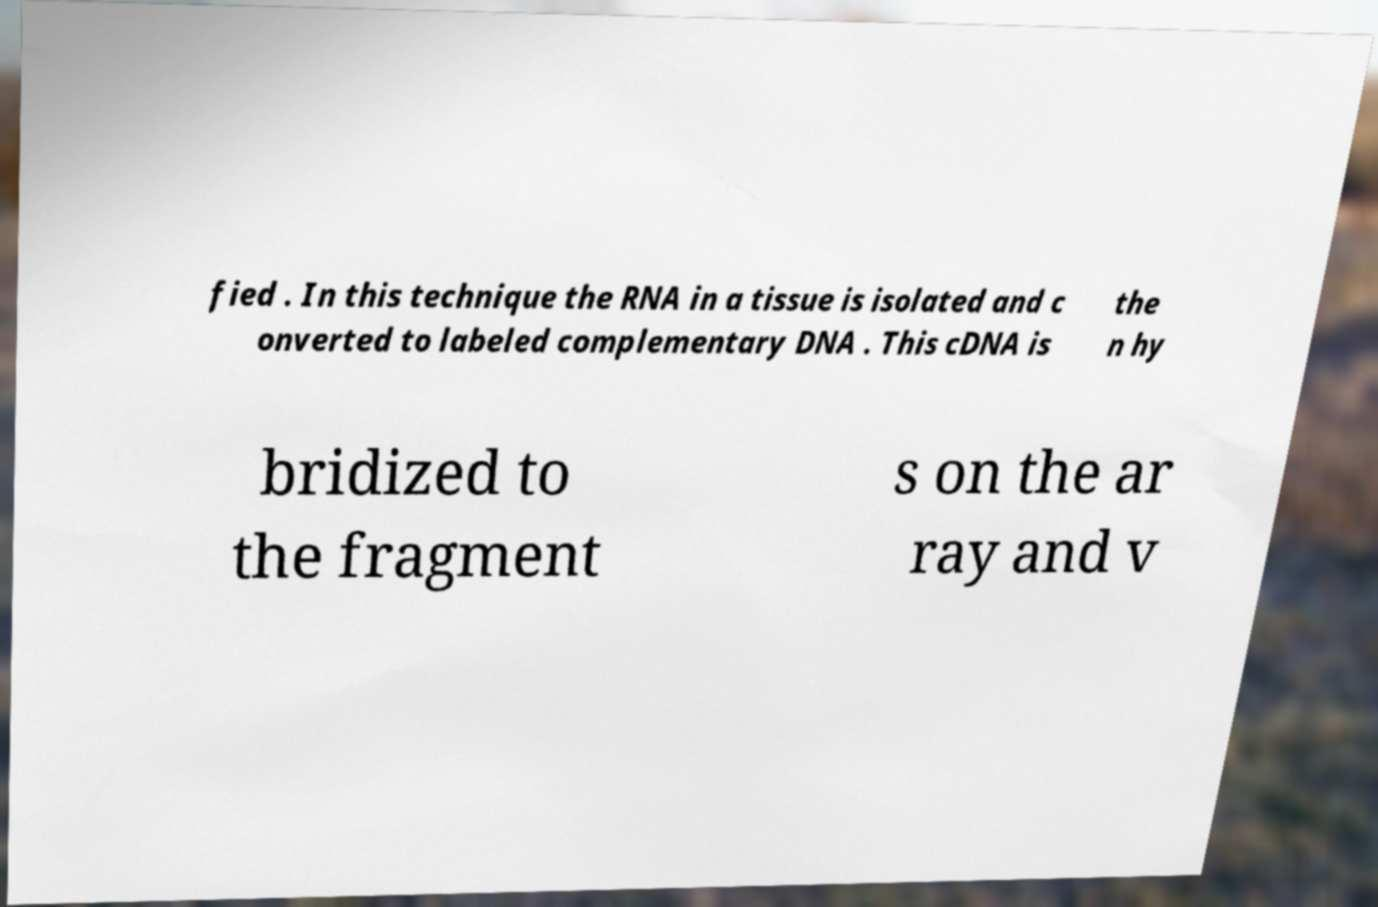Please read and relay the text visible in this image. What does it say? fied . In this technique the RNA in a tissue is isolated and c onverted to labeled complementary DNA . This cDNA is the n hy bridized to the fragment s on the ar ray and v 